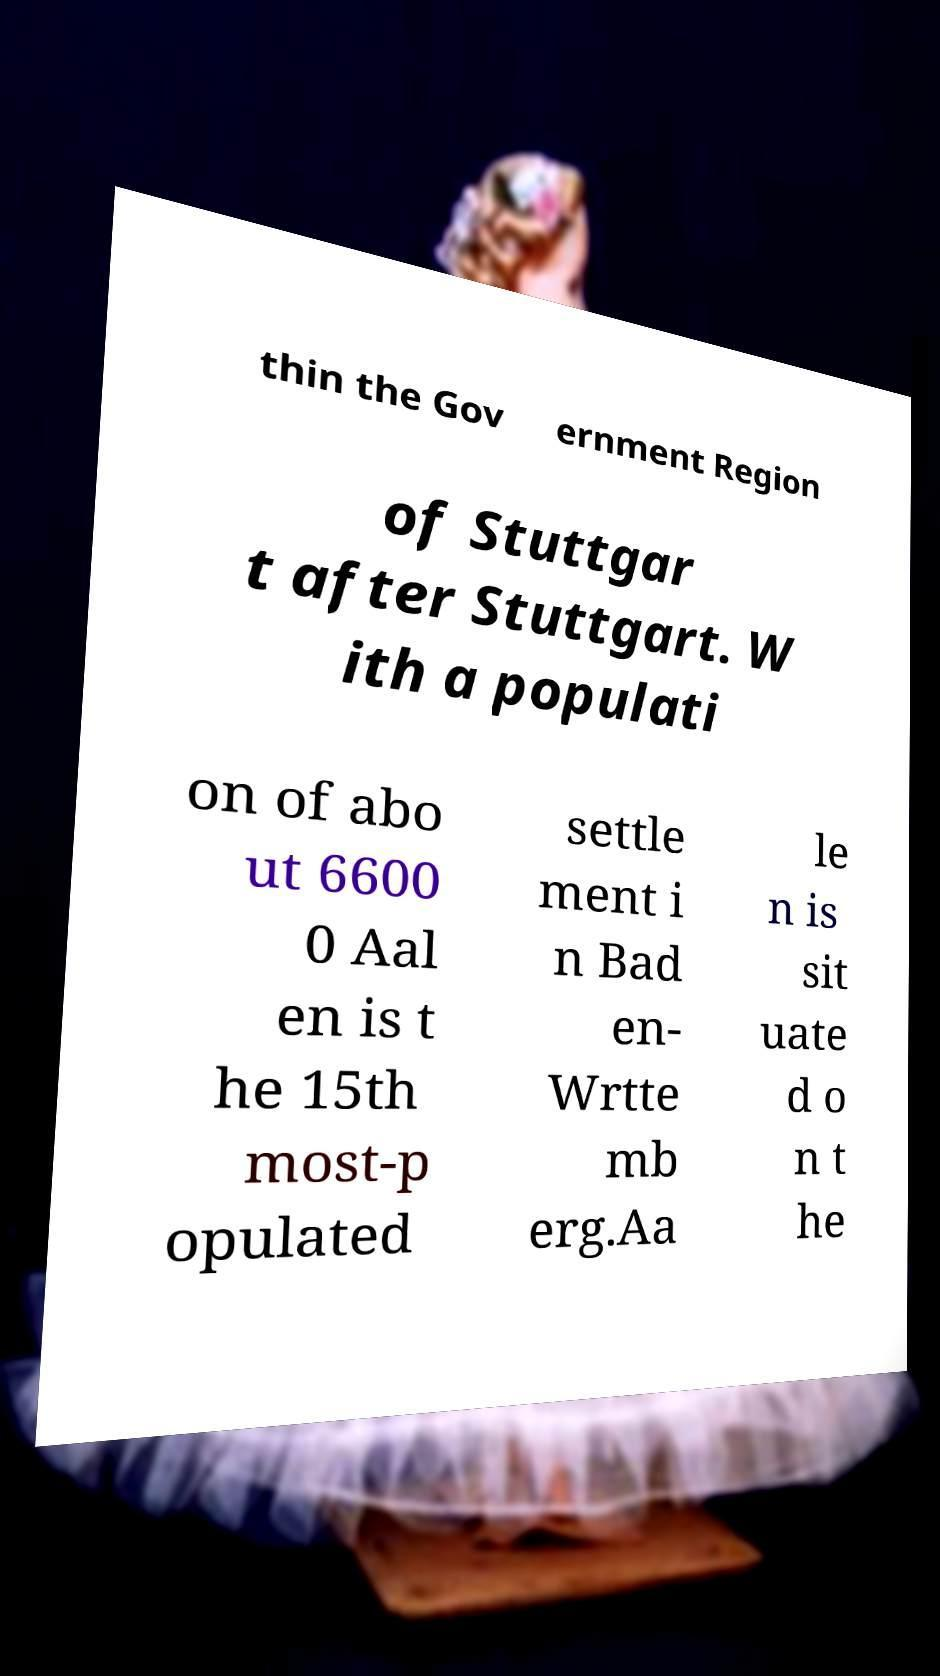Could you assist in decoding the text presented in this image and type it out clearly? thin the Gov ernment Region of Stuttgar t after Stuttgart. W ith a populati on of abo ut 6600 0 Aal en is t he 15th most-p opulated settle ment i n Bad en- Wrtte mb erg.Aa le n is sit uate d o n t he 